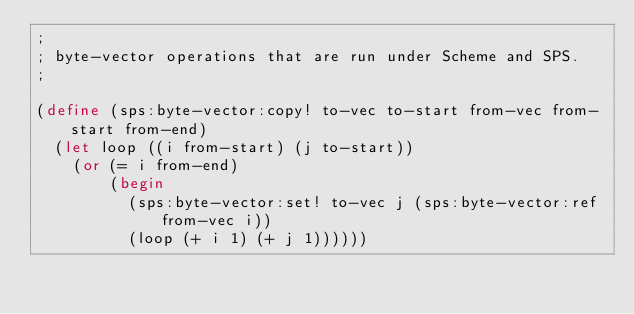Convert code to text. <code><loc_0><loc_0><loc_500><loc_500><_Scheme_>;
; byte-vector operations that are run under Scheme and SPS.
;

(define (sps:byte-vector:copy! to-vec to-start from-vec from-start from-end)
  (let loop ((i from-start) (j to-start))
    (or (= i from-end)
        (begin
          (sps:byte-vector:set! to-vec j (sps:byte-vector:ref from-vec i))
          (loop (+ i 1) (+ j 1))))))
</code> 